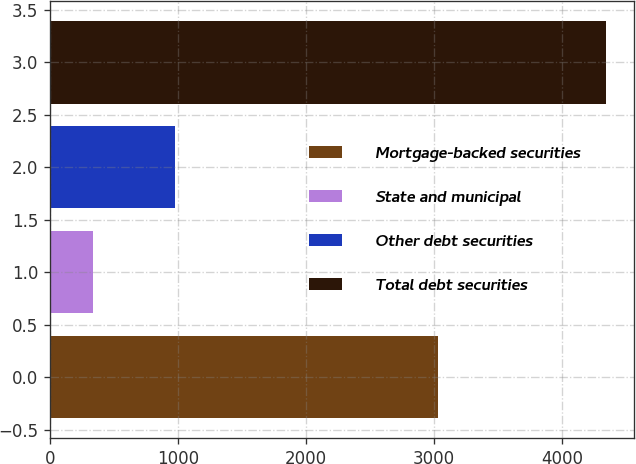<chart> <loc_0><loc_0><loc_500><loc_500><bar_chart><fcel>Mortgage-backed securities<fcel>State and municipal<fcel>Other debt securities<fcel>Total debt securities<nl><fcel>3030<fcel>339<fcel>973<fcel>4342<nl></chart> 